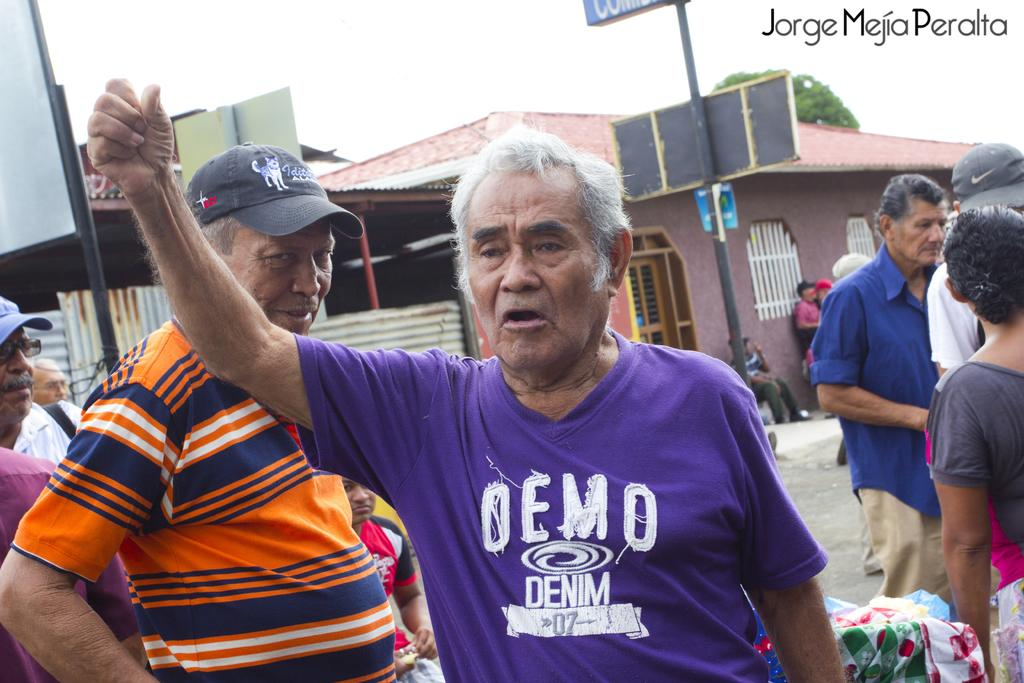How many people are in the image? There are persons standing in the image. What objects are visible in the image besides the people? Clothes, poles, boards, buildings, and a green tree are visible in the image. What can be seen in the background of the image? The sky is visible in the background of the image. What is the mass of the wealth depicted in the image? There is no wealth depicted in the image, so it is not possible to determine its mass. 